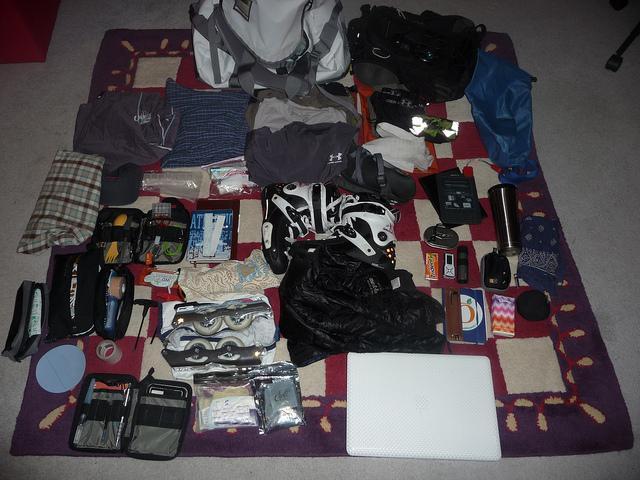Items here are laid out due to what purpose?
Answer the question by selecting the correct answer among the 4 following choices and explain your choice with a short sentence. The answer should be formatted with the following format: `Answer: choice
Rationale: rationale.`
Options: Display wealth, packing backpack, moving sale, manic behaviour. Answer: packing backpack.
Rationale: The empty backpack can be seen at the top of the image. 